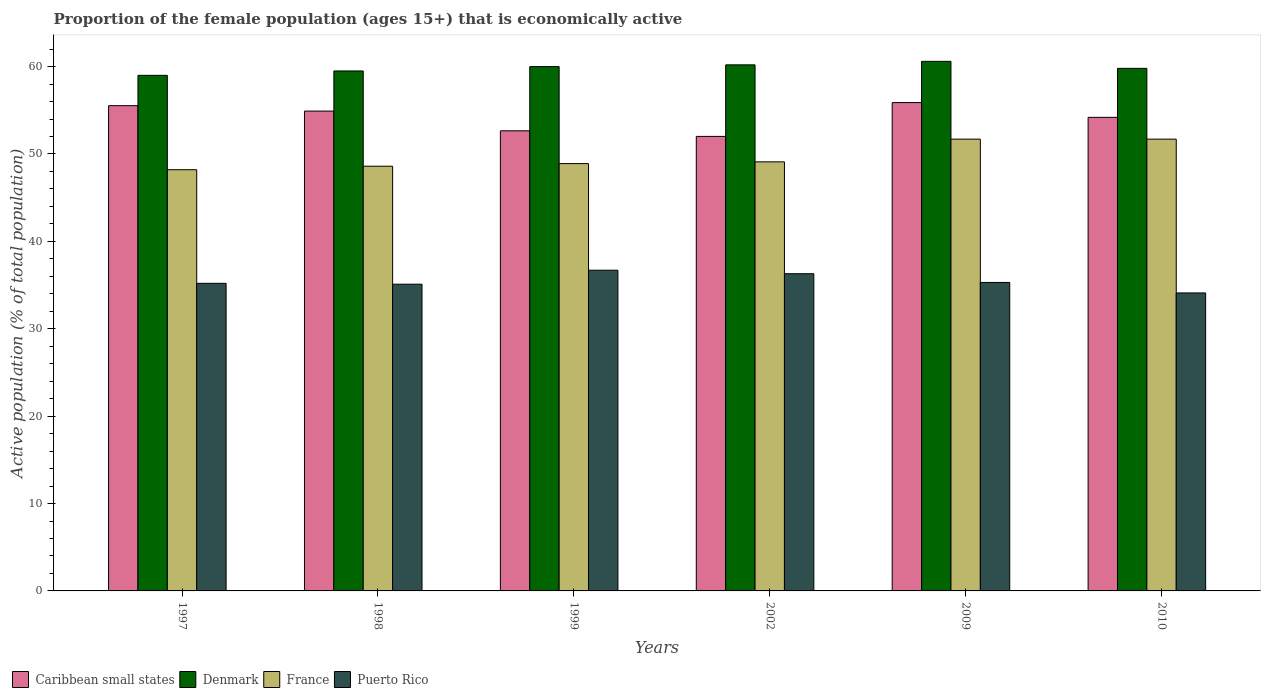Are the number of bars per tick equal to the number of legend labels?
Offer a very short reply. Yes. What is the proportion of the female population that is economically active in Puerto Rico in 1999?
Provide a succinct answer. 36.7. Across all years, what is the maximum proportion of the female population that is economically active in Denmark?
Provide a short and direct response. 60.6. Across all years, what is the minimum proportion of the female population that is economically active in Denmark?
Your answer should be compact. 59. In which year was the proportion of the female population that is economically active in Denmark maximum?
Your answer should be compact. 2009. What is the total proportion of the female population that is economically active in Caribbean small states in the graph?
Provide a succinct answer. 325.18. What is the difference between the proportion of the female population that is economically active in France in 1997 and the proportion of the female population that is economically active in Puerto Rico in 2009?
Keep it short and to the point. 12.9. What is the average proportion of the female population that is economically active in Denmark per year?
Ensure brevity in your answer.  59.85. In the year 1999, what is the difference between the proportion of the female population that is economically active in Denmark and proportion of the female population that is economically active in France?
Keep it short and to the point. 11.1. In how many years, is the proportion of the female population that is economically active in Denmark greater than 18 %?
Give a very brief answer. 6. What is the ratio of the proportion of the female population that is economically active in Denmark in 1998 to that in 1999?
Ensure brevity in your answer.  0.99. Is the difference between the proportion of the female population that is economically active in Denmark in 1999 and 2009 greater than the difference between the proportion of the female population that is economically active in France in 1999 and 2009?
Provide a short and direct response. Yes. What is the difference between the highest and the second highest proportion of the female population that is economically active in Denmark?
Keep it short and to the point. 0.4. Is it the case that in every year, the sum of the proportion of the female population that is economically active in Puerto Rico and proportion of the female population that is economically active in France is greater than the sum of proportion of the female population that is economically active in Caribbean small states and proportion of the female population that is economically active in Denmark?
Give a very brief answer. No. What does the 1st bar from the left in 2009 represents?
Keep it short and to the point. Caribbean small states. Is it the case that in every year, the sum of the proportion of the female population that is economically active in France and proportion of the female population that is economically active in Caribbean small states is greater than the proportion of the female population that is economically active in Puerto Rico?
Offer a terse response. Yes. How many years are there in the graph?
Offer a very short reply. 6. Are the values on the major ticks of Y-axis written in scientific E-notation?
Give a very brief answer. No. Where does the legend appear in the graph?
Offer a terse response. Bottom left. How are the legend labels stacked?
Ensure brevity in your answer.  Horizontal. What is the title of the graph?
Your answer should be compact. Proportion of the female population (ages 15+) that is economically active. Does "Small states" appear as one of the legend labels in the graph?
Your answer should be compact. No. What is the label or title of the Y-axis?
Your response must be concise. Active population (% of total population). What is the Active population (% of total population) of Caribbean small states in 1997?
Give a very brief answer. 55.53. What is the Active population (% of total population) of France in 1997?
Ensure brevity in your answer.  48.2. What is the Active population (% of total population) of Puerto Rico in 1997?
Provide a succinct answer. 35.2. What is the Active population (% of total population) of Caribbean small states in 1998?
Give a very brief answer. 54.91. What is the Active population (% of total population) of Denmark in 1998?
Provide a short and direct response. 59.5. What is the Active population (% of total population) of France in 1998?
Provide a short and direct response. 48.6. What is the Active population (% of total population) in Puerto Rico in 1998?
Ensure brevity in your answer.  35.1. What is the Active population (% of total population) of Caribbean small states in 1999?
Ensure brevity in your answer.  52.65. What is the Active population (% of total population) in Denmark in 1999?
Your answer should be very brief. 60. What is the Active population (% of total population) in France in 1999?
Your answer should be compact. 48.9. What is the Active population (% of total population) in Puerto Rico in 1999?
Keep it short and to the point. 36.7. What is the Active population (% of total population) in Caribbean small states in 2002?
Provide a succinct answer. 52.01. What is the Active population (% of total population) in Denmark in 2002?
Your response must be concise. 60.2. What is the Active population (% of total population) in France in 2002?
Give a very brief answer. 49.1. What is the Active population (% of total population) in Puerto Rico in 2002?
Your response must be concise. 36.3. What is the Active population (% of total population) of Caribbean small states in 2009?
Your response must be concise. 55.88. What is the Active population (% of total population) of Denmark in 2009?
Your answer should be compact. 60.6. What is the Active population (% of total population) of France in 2009?
Provide a succinct answer. 51.7. What is the Active population (% of total population) of Puerto Rico in 2009?
Offer a terse response. 35.3. What is the Active population (% of total population) in Caribbean small states in 2010?
Provide a short and direct response. 54.19. What is the Active population (% of total population) in Denmark in 2010?
Offer a very short reply. 59.8. What is the Active population (% of total population) of France in 2010?
Give a very brief answer. 51.7. What is the Active population (% of total population) of Puerto Rico in 2010?
Provide a succinct answer. 34.1. Across all years, what is the maximum Active population (% of total population) of Caribbean small states?
Your response must be concise. 55.88. Across all years, what is the maximum Active population (% of total population) of Denmark?
Your response must be concise. 60.6. Across all years, what is the maximum Active population (% of total population) of France?
Your answer should be compact. 51.7. Across all years, what is the maximum Active population (% of total population) in Puerto Rico?
Make the answer very short. 36.7. Across all years, what is the minimum Active population (% of total population) in Caribbean small states?
Make the answer very short. 52.01. Across all years, what is the minimum Active population (% of total population) in France?
Your response must be concise. 48.2. Across all years, what is the minimum Active population (% of total population) in Puerto Rico?
Offer a terse response. 34.1. What is the total Active population (% of total population) of Caribbean small states in the graph?
Keep it short and to the point. 325.18. What is the total Active population (% of total population) of Denmark in the graph?
Provide a succinct answer. 359.1. What is the total Active population (% of total population) in France in the graph?
Offer a very short reply. 298.2. What is the total Active population (% of total population) in Puerto Rico in the graph?
Provide a succinct answer. 212.7. What is the difference between the Active population (% of total population) in Caribbean small states in 1997 and that in 1998?
Your answer should be compact. 0.62. What is the difference between the Active population (% of total population) of Caribbean small states in 1997 and that in 1999?
Provide a short and direct response. 2.88. What is the difference between the Active population (% of total population) of Denmark in 1997 and that in 1999?
Offer a terse response. -1. What is the difference between the Active population (% of total population) in Puerto Rico in 1997 and that in 1999?
Provide a short and direct response. -1.5. What is the difference between the Active population (% of total population) in Caribbean small states in 1997 and that in 2002?
Ensure brevity in your answer.  3.52. What is the difference between the Active population (% of total population) in Denmark in 1997 and that in 2002?
Provide a succinct answer. -1.2. What is the difference between the Active population (% of total population) of France in 1997 and that in 2002?
Offer a terse response. -0.9. What is the difference between the Active population (% of total population) in Caribbean small states in 1997 and that in 2009?
Your answer should be very brief. -0.35. What is the difference between the Active population (% of total population) of France in 1997 and that in 2009?
Your answer should be very brief. -3.5. What is the difference between the Active population (% of total population) of Caribbean small states in 1997 and that in 2010?
Your answer should be very brief. 1.34. What is the difference between the Active population (% of total population) in France in 1997 and that in 2010?
Your answer should be very brief. -3.5. What is the difference between the Active population (% of total population) in Caribbean small states in 1998 and that in 1999?
Provide a short and direct response. 2.26. What is the difference between the Active population (% of total population) of Puerto Rico in 1998 and that in 1999?
Your answer should be compact. -1.6. What is the difference between the Active population (% of total population) in Caribbean small states in 1998 and that in 2002?
Keep it short and to the point. 2.9. What is the difference between the Active population (% of total population) in France in 1998 and that in 2002?
Ensure brevity in your answer.  -0.5. What is the difference between the Active population (% of total population) of Caribbean small states in 1998 and that in 2009?
Make the answer very short. -0.97. What is the difference between the Active population (% of total population) of Denmark in 1998 and that in 2009?
Provide a succinct answer. -1.1. What is the difference between the Active population (% of total population) in Caribbean small states in 1998 and that in 2010?
Offer a very short reply. 0.72. What is the difference between the Active population (% of total population) in Puerto Rico in 1998 and that in 2010?
Offer a very short reply. 1. What is the difference between the Active population (% of total population) in Caribbean small states in 1999 and that in 2002?
Provide a short and direct response. 0.64. What is the difference between the Active population (% of total population) in Caribbean small states in 1999 and that in 2009?
Keep it short and to the point. -3.23. What is the difference between the Active population (% of total population) of Denmark in 1999 and that in 2009?
Offer a terse response. -0.6. What is the difference between the Active population (% of total population) of France in 1999 and that in 2009?
Offer a very short reply. -2.8. What is the difference between the Active population (% of total population) of Caribbean small states in 1999 and that in 2010?
Offer a terse response. -1.54. What is the difference between the Active population (% of total population) of Denmark in 1999 and that in 2010?
Provide a succinct answer. 0.2. What is the difference between the Active population (% of total population) in France in 1999 and that in 2010?
Your answer should be compact. -2.8. What is the difference between the Active population (% of total population) in Caribbean small states in 2002 and that in 2009?
Give a very brief answer. -3.87. What is the difference between the Active population (% of total population) in Denmark in 2002 and that in 2009?
Give a very brief answer. -0.4. What is the difference between the Active population (% of total population) in France in 2002 and that in 2009?
Your answer should be compact. -2.6. What is the difference between the Active population (% of total population) in Caribbean small states in 2002 and that in 2010?
Make the answer very short. -2.18. What is the difference between the Active population (% of total population) in Denmark in 2002 and that in 2010?
Ensure brevity in your answer.  0.4. What is the difference between the Active population (% of total population) in Puerto Rico in 2002 and that in 2010?
Offer a very short reply. 2.2. What is the difference between the Active population (% of total population) of Caribbean small states in 2009 and that in 2010?
Provide a succinct answer. 1.69. What is the difference between the Active population (% of total population) in Denmark in 2009 and that in 2010?
Ensure brevity in your answer.  0.8. What is the difference between the Active population (% of total population) of Caribbean small states in 1997 and the Active population (% of total population) of Denmark in 1998?
Make the answer very short. -3.97. What is the difference between the Active population (% of total population) of Caribbean small states in 1997 and the Active population (% of total population) of France in 1998?
Keep it short and to the point. 6.93. What is the difference between the Active population (% of total population) of Caribbean small states in 1997 and the Active population (% of total population) of Puerto Rico in 1998?
Your answer should be compact. 20.43. What is the difference between the Active population (% of total population) of Denmark in 1997 and the Active population (% of total population) of France in 1998?
Make the answer very short. 10.4. What is the difference between the Active population (% of total population) in Denmark in 1997 and the Active population (% of total population) in Puerto Rico in 1998?
Offer a very short reply. 23.9. What is the difference between the Active population (% of total population) in Caribbean small states in 1997 and the Active population (% of total population) in Denmark in 1999?
Make the answer very short. -4.47. What is the difference between the Active population (% of total population) of Caribbean small states in 1997 and the Active population (% of total population) of France in 1999?
Your answer should be very brief. 6.63. What is the difference between the Active population (% of total population) of Caribbean small states in 1997 and the Active population (% of total population) of Puerto Rico in 1999?
Keep it short and to the point. 18.83. What is the difference between the Active population (% of total population) in Denmark in 1997 and the Active population (% of total population) in France in 1999?
Make the answer very short. 10.1. What is the difference between the Active population (% of total population) of Denmark in 1997 and the Active population (% of total population) of Puerto Rico in 1999?
Your answer should be very brief. 22.3. What is the difference between the Active population (% of total population) in Caribbean small states in 1997 and the Active population (% of total population) in Denmark in 2002?
Offer a very short reply. -4.67. What is the difference between the Active population (% of total population) in Caribbean small states in 1997 and the Active population (% of total population) in France in 2002?
Your answer should be very brief. 6.43. What is the difference between the Active population (% of total population) of Caribbean small states in 1997 and the Active population (% of total population) of Puerto Rico in 2002?
Keep it short and to the point. 19.23. What is the difference between the Active population (% of total population) in Denmark in 1997 and the Active population (% of total population) in France in 2002?
Your answer should be very brief. 9.9. What is the difference between the Active population (% of total population) in Denmark in 1997 and the Active population (% of total population) in Puerto Rico in 2002?
Give a very brief answer. 22.7. What is the difference between the Active population (% of total population) of Caribbean small states in 1997 and the Active population (% of total population) of Denmark in 2009?
Offer a very short reply. -5.07. What is the difference between the Active population (% of total population) of Caribbean small states in 1997 and the Active population (% of total population) of France in 2009?
Ensure brevity in your answer.  3.83. What is the difference between the Active population (% of total population) in Caribbean small states in 1997 and the Active population (% of total population) in Puerto Rico in 2009?
Ensure brevity in your answer.  20.23. What is the difference between the Active population (% of total population) of Denmark in 1997 and the Active population (% of total population) of France in 2009?
Offer a very short reply. 7.3. What is the difference between the Active population (% of total population) of Denmark in 1997 and the Active population (% of total population) of Puerto Rico in 2009?
Your answer should be compact. 23.7. What is the difference between the Active population (% of total population) in Caribbean small states in 1997 and the Active population (% of total population) in Denmark in 2010?
Offer a terse response. -4.27. What is the difference between the Active population (% of total population) of Caribbean small states in 1997 and the Active population (% of total population) of France in 2010?
Provide a succinct answer. 3.83. What is the difference between the Active population (% of total population) in Caribbean small states in 1997 and the Active population (% of total population) in Puerto Rico in 2010?
Provide a succinct answer. 21.43. What is the difference between the Active population (% of total population) in Denmark in 1997 and the Active population (% of total population) in France in 2010?
Your answer should be compact. 7.3. What is the difference between the Active population (% of total population) of Denmark in 1997 and the Active population (% of total population) of Puerto Rico in 2010?
Offer a very short reply. 24.9. What is the difference between the Active population (% of total population) of France in 1997 and the Active population (% of total population) of Puerto Rico in 2010?
Your answer should be very brief. 14.1. What is the difference between the Active population (% of total population) of Caribbean small states in 1998 and the Active population (% of total population) of Denmark in 1999?
Provide a succinct answer. -5.09. What is the difference between the Active population (% of total population) in Caribbean small states in 1998 and the Active population (% of total population) in France in 1999?
Your answer should be very brief. 6.01. What is the difference between the Active population (% of total population) in Caribbean small states in 1998 and the Active population (% of total population) in Puerto Rico in 1999?
Give a very brief answer. 18.21. What is the difference between the Active population (% of total population) in Denmark in 1998 and the Active population (% of total population) in France in 1999?
Make the answer very short. 10.6. What is the difference between the Active population (% of total population) of Denmark in 1998 and the Active population (% of total population) of Puerto Rico in 1999?
Your answer should be compact. 22.8. What is the difference between the Active population (% of total population) in France in 1998 and the Active population (% of total population) in Puerto Rico in 1999?
Your response must be concise. 11.9. What is the difference between the Active population (% of total population) in Caribbean small states in 1998 and the Active population (% of total population) in Denmark in 2002?
Your answer should be very brief. -5.29. What is the difference between the Active population (% of total population) in Caribbean small states in 1998 and the Active population (% of total population) in France in 2002?
Your answer should be very brief. 5.81. What is the difference between the Active population (% of total population) of Caribbean small states in 1998 and the Active population (% of total population) of Puerto Rico in 2002?
Ensure brevity in your answer.  18.61. What is the difference between the Active population (% of total population) of Denmark in 1998 and the Active population (% of total population) of Puerto Rico in 2002?
Give a very brief answer. 23.2. What is the difference between the Active population (% of total population) in France in 1998 and the Active population (% of total population) in Puerto Rico in 2002?
Provide a succinct answer. 12.3. What is the difference between the Active population (% of total population) of Caribbean small states in 1998 and the Active population (% of total population) of Denmark in 2009?
Provide a succinct answer. -5.69. What is the difference between the Active population (% of total population) in Caribbean small states in 1998 and the Active population (% of total population) in France in 2009?
Provide a short and direct response. 3.21. What is the difference between the Active population (% of total population) in Caribbean small states in 1998 and the Active population (% of total population) in Puerto Rico in 2009?
Ensure brevity in your answer.  19.61. What is the difference between the Active population (% of total population) in Denmark in 1998 and the Active population (% of total population) in France in 2009?
Make the answer very short. 7.8. What is the difference between the Active population (% of total population) of Denmark in 1998 and the Active population (% of total population) of Puerto Rico in 2009?
Give a very brief answer. 24.2. What is the difference between the Active population (% of total population) of France in 1998 and the Active population (% of total population) of Puerto Rico in 2009?
Offer a very short reply. 13.3. What is the difference between the Active population (% of total population) of Caribbean small states in 1998 and the Active population (% of total population) of Denmark in 2010?
Your answer should be very brief. -4.89. What is the difference between the Active population (% of total population) of Caribbean small states in 1998 and the Active population (% of total population) of France in 2010?
Provide a short and direct response. 3.21. What is the difference between the Active population (% of total population) in Caribbean small states in 1998 and the Active population (% of total population) in Puerto Rico in 2010?
Your answer should be very brief. 20.81. What is the difference between the Active population (% of total population) of Denmark in 1998 and the Active population (% of total population) of Puerto Rico in 2010?
Provide a succinct answer. 25.4. What is the difference between the Active population (% of total population) of Caribbean small states in 1999 and the Active population (% of total population) of Denmark in 2002?
Keep it short and to the point. -7.55. What is the difference between the Active population (% of total population) in Caribbean small states in 1999 and the Active population (% of total population) in France in 2002?
Give a very brief answer. 3.55. What is the difference between the Active population (% of total population) of Caribbean small states in 1999 and the Active population (% of total population) of Puerto Rico in 2002?
Your response must be concise. 16.35. What is the difference between the Active population (% of total population) of Denmark in 1999 and the Active population (% of total population) of Puerto Rico in 2002?
Ensure brevity in your answer.  23.7. What is the difference between the Active population (% of total population) in France in 1999 and the Active population (% of total population) in Puerto Rico in 2002?
Provide a succinct answer. 12.6. What is the difference between the Active population (% of total population) in Caribbean small states in 1999 and the Active population (% of total population) in Denmark in 2009?
Give a very brief answer. -7.95. What is the difference between the Active population (% of total population) of Caribbean small states in 1999 and the Active population (% of total population) of France in 2009?
Your answer should be compact. 0.95. What is the difference between the Active population (% of total population) in Caribbean small states in 1999 and the Active population (% of total population) in Puerto Rico in 2009?
Ensure brevity in your answer.  17.35. What is the difference between the Active population (% of total population) in Denmark in 1999 and the Active population (% of total population) in France in 2009?
Offer a terse response. 8.3. What is the difference between the Active population (% of total population) in Denmark in 1999 and the Active population (% of total population) in Puerto Rico in 2009?
Your response must be concise. 24.7. What is the difference between the Active population (% of total population) in Caribbean small states in 1999 and the Active population (% of total population) in Denmark in 2010?
Offer a terse response. -7.15. What is the difference between the Active population (% of total population) of Caribbean small states in 1999 and the Active population (% of total population) of France in 2010?
Give a very brief answer. 0.95. What is the difference between the Active population (% of total population) of Caribbean small states in 1999 and the Active population (% of total population) of Puerto Rico in 2010?
Offer a terse response. 18.55. What is the difference between the Active population (% of total population) in Denmark in 1999 and the Active population (% of total population) in Puerto Rico in 2010?
Offer a terse response. 25.9. What is the difference between the Active population (% of total population) of Caribbean small states in 2002 and the Active population (% of total population) of Denmark in 2009?
Make the answer very short. -8.59. What is the difference between the Active population (% of total population) of Caribbean small states in 2002 and the Active population (% of total population) of France in 2009?
Provide a succinct answer. 0.31. What is the difference between the Active population (% of total population) of Caribbean small states in 2002 and the Active population (% of total population) of Puerto Rico in 2009?
Offer a very short reply. 16.71. What is the difference between the Active population (% of total population) in Denmark in 2002 and the Active population (% of total population) in Puerto Rico in 2009?
Your answer should be compact. 24.9. What is the difference between the Active population (% of total population) in France in 2002 and the Active population (% of total population) in Puerto Rico in 2009?
Your response must be concise. 13.8. What is the difference between the Active population (% of total population) of Caribbean small states in 2002 and the Active population (% of total population) of Denmark in 2010?
Make the answer very short. -7.79. What is the difference between the Active population (% of total population) in Caribbean small states in 2002 and the Active population (% of total population) in France in 2010?
Keep it short and to the point. 0.31. What is the difference between the Active population (% of total population) in Caribbean small states in 2002 and the Active population (% of total population) in Puerto Rico in 2010?
Offer a very short reply. 17.91. What is the difference between the Active population (% of total population) in Denmark in 2002 and the Active population (% of total population) in France in 2010?
Your answer should be very brief. 8.5. What is the difference between the Active population (% of total population) of Denmark in 2002 and the Active population (% of total population) of Puerto Rico in 2010?
Keep it short and to the point. 26.1. What is the difference between the Active population (% of total population) of Caribbean small states in 2009 and the Active population (% of total population) of Denmark in 2010?
Make the answer very short. -3.92. What is the difference between the Active population (% of total population) in Caribbean small states in 2009 and the Active population (% of total population) in France in 2010?
Ensure brevity in your answer.  4.18. What is the difference between the Active population (% of total population) of Caribbean small states in 2009 and the Active population (% of total population) of Puerto Rico in 2010?
Offer a very short reply. 21.78. What is the difference between the Active population (% of total population) in Denmark in 2009 and the Active population (% of total population) in France in 2010?
Provide a short and direct response. 8.9. What is the difference between the Active population (% of total population) in Denmark in 2009 and the Active population (% of total population) in Puerto Rico in 2010?
Provide a short and direct response. 26.5. What is the difference between the Active population (% of total population) of France in 2009 and the Active population (% of total population) of Puerto Rico in 2010?
Your answer should be very brief. 17.6. What is the average Active population (% of total population) in Caribbean small states per year?
Your answer should be compact. 54.2. What is the average Active population (% of total population) in Denmark per year?
Provide a short and direct response. 59.85. What is the average Active population (% of total population) in France per year?
Your answer should be very brief. 49.7. What is the average Active population (% of total population) in Puerto Rico per year?
Keep it short and to the point. 35.45. In the year 1997, what is the difference between the Active population (% of total population) of Caribbean small states and Active population (% of total population) of Denmark?
Keep it short and to the point. -3.47. In the year 1997, what is the difference between the Active population (% of total population) in Caribbean small states and Active population (% of total population) in France?
Your response must be concise. 7.33. In the year 1997, what is the difference between the Active population (% of total population) of Caribbean small states and Active population (% of total population) of Puerto Rico?
Your answer should be compact. 20.33. In the year 1997, what is the difference between the Active population (% of total population) in Denmark and Active population (% of total population) in France?
Your answer should be compact. 10.8. In the year 1997, what is the difference between the Active population (% of total population) of Denmark and Active population (% of total population) of Puerto Rico?
Keep it short and to the point. 23.8. In the year 1998, what is the difference between the Active population (% of total population) of Caribbean small states and Active population (% of total population) of Denmark?
Offer a very short reply. -4.59. In the year 1998, what is the difference between the Active population (% of total population) in Caribbean small states and Active population (% of total population) in France?
Offer a terse response. 6.31. In the year 1998, what is the difference between the Active population (% of total population) in Caribbean small states and Active population (% of total population) in Puerto Rico?
Provide a succinct answer. 19.81. In the year 1998, what is the difference between the Active population (% of total population) in Denmark and Active population (% of total population) in France?
Offer a terse response. 10.9. In the year 1998, what is the difference between the Active population (% of total population) in Denmark and Active population (% of total population) in Puerto Rico?
Give a very brief answer. 24.4. In the year 1998, what is the difference between the Active population (% of total population) of France and Active population (% of total population) of Puerto Rico?
Offer a very short reply. 13.5. In the year 1999, what is the difference between the Active population (% of total population) in Caribbean small states and Active population (% of total population) in Denmark?
Provide a short and direct response. -7.35. In the year 1999, what is the difference between the Active population (% of total population) of Caribbean small states and Active population (% of total population) of France?
Your response must be concise. 3.75. In the year 1999, what is the difference between the Active population (% of total population) in Caribbean small states and Active population (% of total population) in Puerto Rico?
Provide a short and direct response. 15.95. In the year 1999, what is the difference between the Active population (% of total population) in Denmark and Active population (% of total population) in France?
Keep it short and to the point. 11.1. In the year 1999, what is the difference between the Active population (% of total population) in Denmark and Active population (% of total population) in Puerto Rico?
Keep it short and to the point. 23.3. In the year 2002, what is the difference between the Active population (% of total population) in Caribbean small states and Active population (% of total population) in Denmark?
Provide a short and direct response. -8.19. In the year 2002, what is the difference between the Active population (% of total population) in Caribbean small states and Active population (% of total population) in France?
Ensure brevity in your answer.  2.91. In the year 2002, what is the difference between the Active population (% of total population) of Caribbean small states and Active population (% of total population) of Puerto Rico?
Your answer should be very brief. 15.71. In the year 2002, what is the difference between the Active population (% of total population) in Denmark and Active population (% of total population) in Puerto Rico?
Your answer should be compact. 23.9. In the year 2002, what is the difference between the Active population (% of total population) of France and Active population (% of total population) of Puerto Rico?
Give a very brief answer. 12.8. In the year 2009, what is the difference between the Active population (% of total population) of Caribbean small states and Active population (% of total population) of Denmark?
Offer a very short reply. -4.72. In the year 2009, what is the difference between the Active population (% of total population) of Caribbean small states and Active population (% of total population) of France?
Keep it short and to the point. 4.18. In the year 2009, what is the difference between the Active population (% of total population) of Caribbean small states and Active population (% of total population) of Puerto Rico?
Give a very brief answer. 20.58. In the year 2009, what is the difference between the Active population (% of total population) in Denmark and Active population (% of total population) in Puerto Rico?
Your answer should be compact. 25.3. In the year 2010, what is the difference between the Active population (% of total population) of Caribbean small states and Active population (% of total population) of Denmark?
Your response must be concise. -5.61. In the year 2010, what is the difference between the Active population (% of total population) in Caribbean small states and Active population (% of total population) in France?
Make the answer very short. 2.49. In the year 2010, what is the difference between the Active population (% of total population) in Caribbean small states and Active population (% of total population) in Puerto Rico?
Your answer should be compact. 20.09. In the year 2010, what is the difference between the Active population (% of total population) in Denmark and Active population (% of total population) in France?
Offer a terse response. 8.1. In the year 2010, what is the difference between the Active population (% of total population) in Denmark and Active population (% of total population) in Puerto Rico?
Keep it short and to the point. 25.7. In the year 2010, what is the difference between the Active population (% of total population) in France and Active population (% of total population) in Puerto Rico?
Keep it short and to the point. 17.6. What is the ratio of the Active population (% of total population) of Caribbean small states in 1997 to that in 1998?
Offer a terse response. 1.01. What is the ratio of the Active population (% of total population) in France in 1997 to that in 1998?
Your answer should be compact. 0.99. What is the ratio of the Active population (% of total population) in Caribbean small states in 1997 to that in 1999?
Your answer should be very brief. 1.05. What is the ratio of the Active population (% of total population) in Denmark in 1997 to that in 1999?
Provide a short and direct response. 0.98. What is the ratio of the Active population (% of total population) in France in 1997 to that in 1999?
Keep it short and to the point. 0.99. What is the ratio of the Active population (% of total population) of Puerto Rico in 1997 to that in 1999?
Give a very brief answer. 0.96. What is the ratio of the Active population (% of total population) in Caribbean small states in 1997 to that in 2002?
Provide a short and direct response. 1.07. What is the ratio of the Active population (% of total population) in Denmark in 1997 to that in 2002?
Offer a very short reply. 0.98. What is the ratio of the Active population (% of total population) of France in 1997 to that in 2002?
Provide a short and direct response. 0.98. What is the ratio of the Active population (% of total population) of Puerto Rico in 1997 to that in 2002?
Your answer should be compact. 0.97. What is the ratio of the Active population (% of total population) of Caribbean small states in 1997 to that in 2009?
Provide a short and direct response. 0.99. What is the ratio of the Active population (% of total population) of Denmark in 1997 to that in 2009?
Keep it short and to the point. 0.97. What is the ratio of the Active population (% of total population) in France in 1997 to that in 2009?
Your answer should be very brief. 0.93. What is the ratio of the Active population (% of total population) in Caribbean small states in 1997 to that in 2010?
Your answer should be compact. 1.02. What is the ratio of the Active population (% of total population) of Denmark in 1997 to that in 2010?
Offer a terse response. 0.99. What is the ratio of the Active population (% of total population) of France in 1997 to that in 2010?
Give a very brief answer. 0.93. What is the ratio of the Active population (% of total population) of Puerto Rico in 1997 to that in 2010?
Offer a very short reply. 1.03. What is the ratio of the Active population (% of total population) in Caribbean small states in 1998 to that in 1999?
Your answer should be very brief. 1.04. What is the ratio of the Active population (% of total population) of France in 1998 to that in 1999?
Provide a succinct answer. 0.99. What is the ratio of the Active population (% of total population) of Puerto Rico in 1998 to that in 1999?
Give a very brief answer. 0.96. What is the ratio of the Active population (% of total population) in Caribbean small states in 1998 to that in 2002?
Make the answer very short. 1.06. What is the ratio of the Active population (% of total population) in Denmark in 1998 to that in 2002?
Ensure brevity in your answer.  0.99. What is the ratio of the Active population (% of total population) in Puerto Rico in 1998 to that in 2002?
Your answer should be very brief. 0.97. What is the ratio of the Active population (% of total population) of Caribbean small states in 1998 to that in 2009?
Make the answer very short. 0.98. What is the ratio of the Active population (% of total population) in Denmark in 1998 to that in 2009?
Make the answer very short. 0.98. What is the ratio of the Active population (% of total population) in Puerto Rico in 1998 to that in 2009?
Keep it short and to the point. 0.99. What is the ratio of the Active population (% of total population) in Caribbean small states in 1998 to that in 2010?
Provide a short and direct response. 1.01. What is the ratio of the Active population (% of total population) of Denmark in 1998 to that in 2010?
Offer a very short reply. 0.99. What is the ratio of the Active population (% of total population) in Puerto Rico in 1998 to that in 2010?
Offer a terse response. 1.03. What is the ratio of the Active population (% of total population) of Caribbean small states in 1999 to that in 2002?
Offer a terse response. 1.01. What is the ratio of the Active population (% of total population) of France in 1999 to that in 2002?
Make the answer very short. 1. What is the ratio of the Active population (% of total population) of Caribbean small states in 1999 to that in 2009?
Your response must be concise. 0.94. What is the ratio of the Active population (% of total population) in France in 1999 to that in 2009?
Keep it short and to the point. 0.95. What is the ratio of the Active population (% of total population) in Puerto Rico in 1999 to that in 2009?
Provide a succinct answer. 1.04. What is the ratio of the Active population (% of total population) of Caribbean small states in 1999 to that in 2010?
Provide a short and direct response. 0.97. What is the ratio of the Active population (% of total population) of Denmark in 1999 to that in 2010?
Make the answer very short. 1. What is the ratio of the Active population (% of total population) in France in 1999 to that in 2010?
Your answer should be very brief. 0.95. What is the ratio of the Active population (% of total population) in Puerto Rico in 1999 to that in 2010?
Provide a short and direct response. 1.08. What is the ratio of the Active population (% of total population) in Caribbean small states in 2002 to that in 2009?
Keep it short and to the point. 0.93. What is the ratio of the Active population (% of total population) of Denmark in 2002 to that in 2009?
Provide a succinct answer. 0.99. What is the ratio of the Active population (% of total population) in France in 2002 to that in 2009?
Give a very brief answer. 0.95. What is the ratio of the Active population (% of total population) of Puerto Rico in 2002 to that in 2009?
Your answer should be very brief. 1.03. What is the ratio of the Active population (% of total population) in Caribbean small states in 2002 to that in 2010?
Provide a succinct answer. 0.96. What is the ratio of the Active population (% of total population) of Denmark in 2002 to that in 2010?
Provide a succinct answer. 1.01. What is the ratio of the Active population (% of total population) in France in 2002 to that in 2010?
Give a very brief answer. 0.95. What is the ratio of the Active population (% of total population) in Puerto Rico in 2002 to that in 2010?
Make the answer very short. 1.06. What is the ratio of the Active population (% of total population) in Caribbean small states in 2009 to that in 2010?
Keep it short and to the point. 1.03. What is the ratio of the Active population (% of total population) of Denmark in 2009 to that in 2010?
Make the answer very short. 1.01. What is the ratio of the Active population (% of total population) in Puerto Rico in 2009 to that in 2010?
Your response must be concise. 1.04. What is the difference between the highest and the second highest Active population (% of total population) in Caribbean small states?
Offer a terse response. 0.35. What is the difference between the highest and the lowest Active population (% of total population) in Caribbean small states?
Your answer should be compact. 3.87. What is the difference between the highest and the lowest Active population (% of total population) in Denmark?
Ensure brevity in your answer.  1.6. 